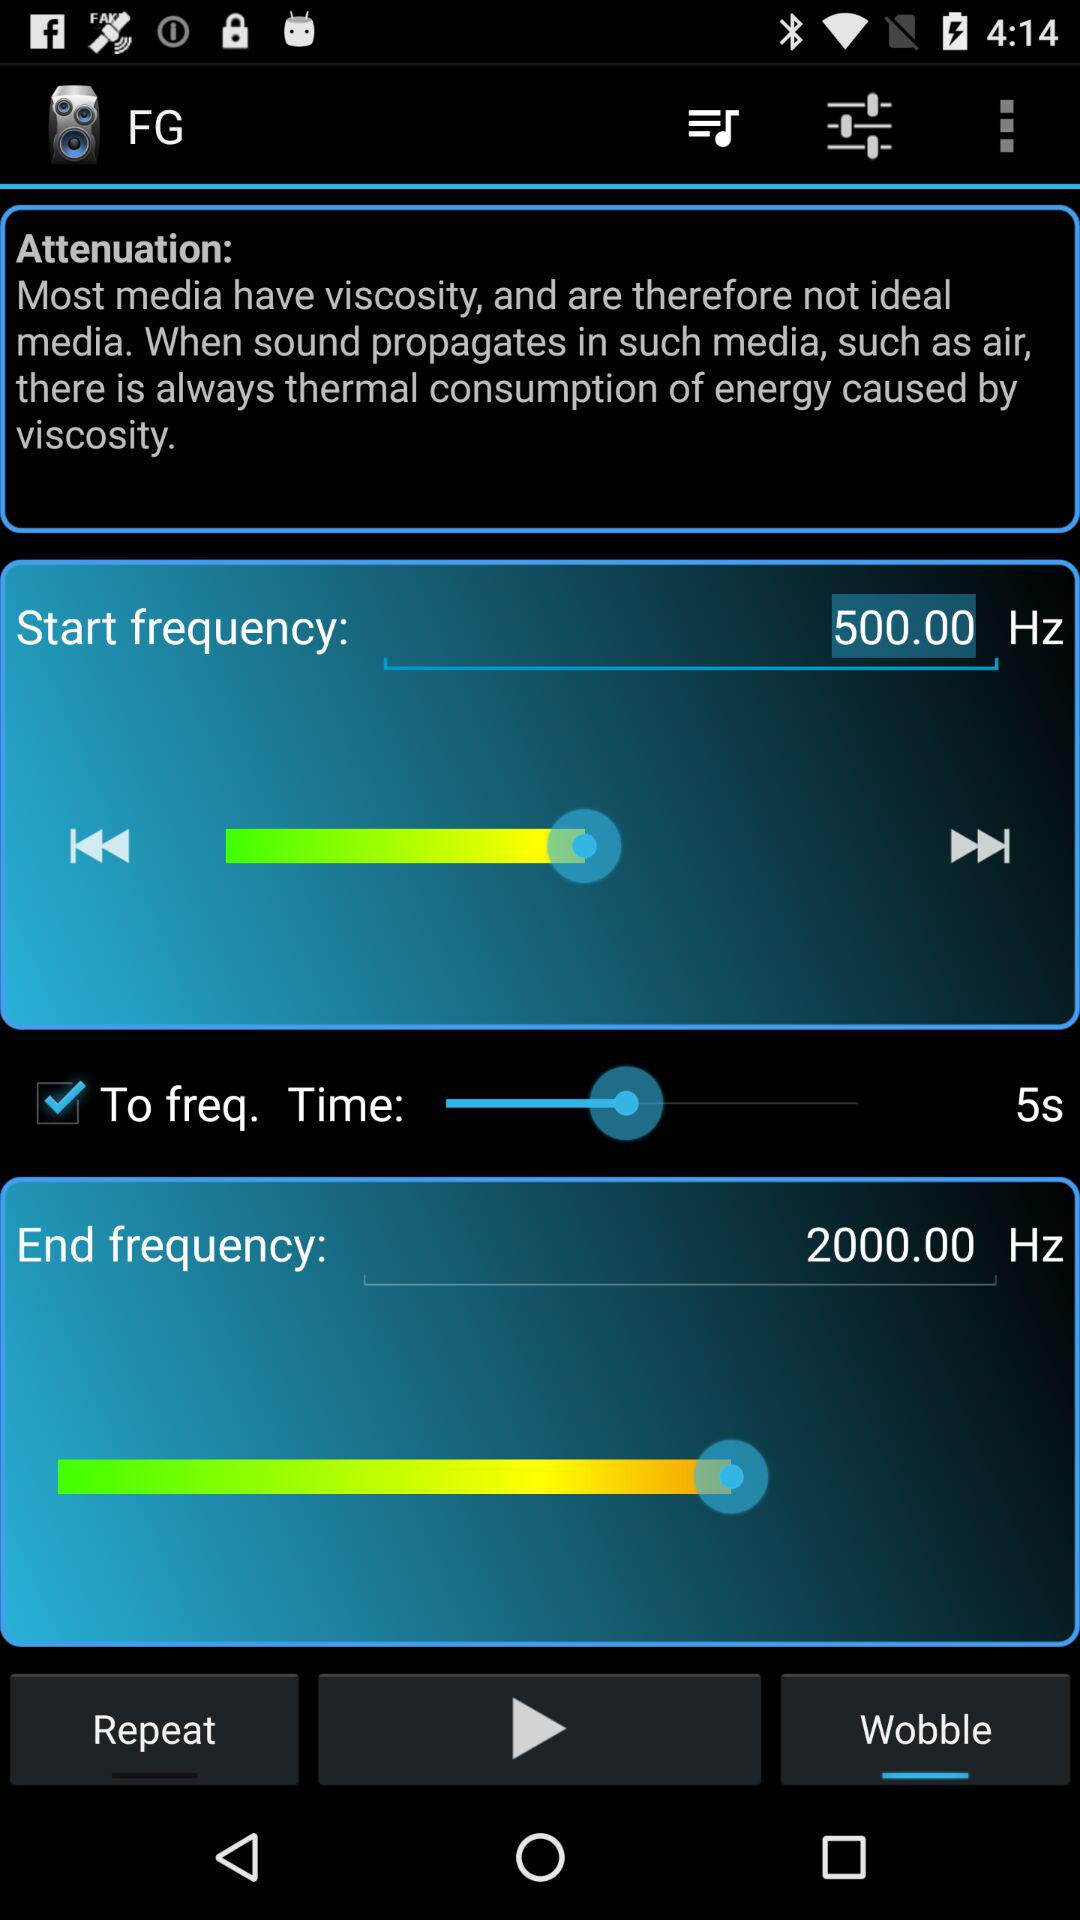How long is the time duration of the attenuation?
Answer the question using a single word or phrase. 5s 